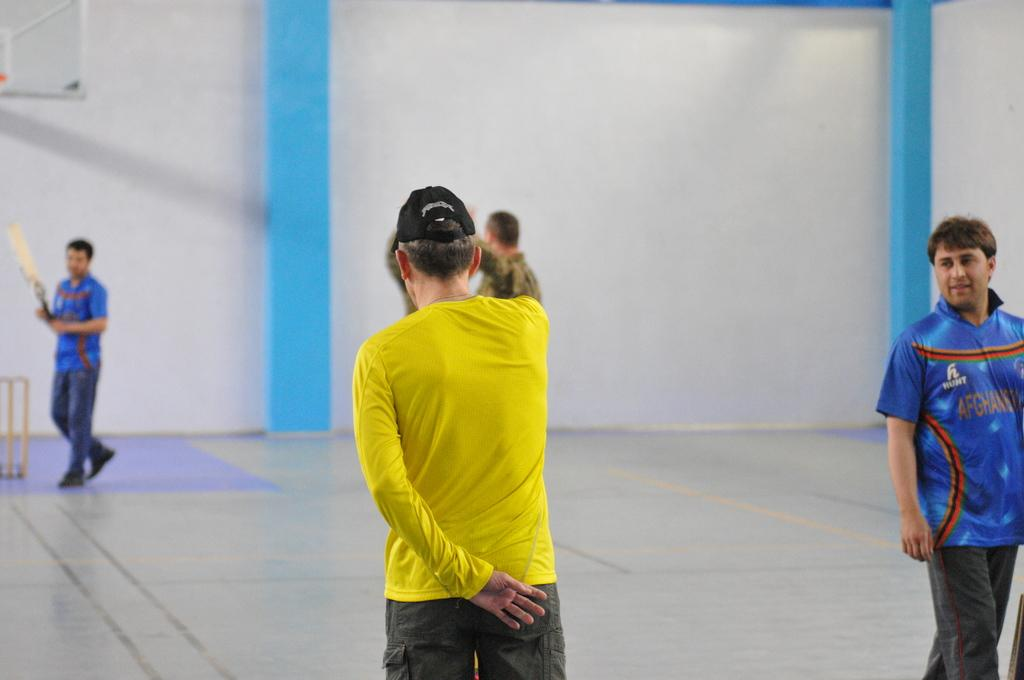<image>
Describe the image concisely. a man in yellow with other people that have the word Hunt on their jerseys 